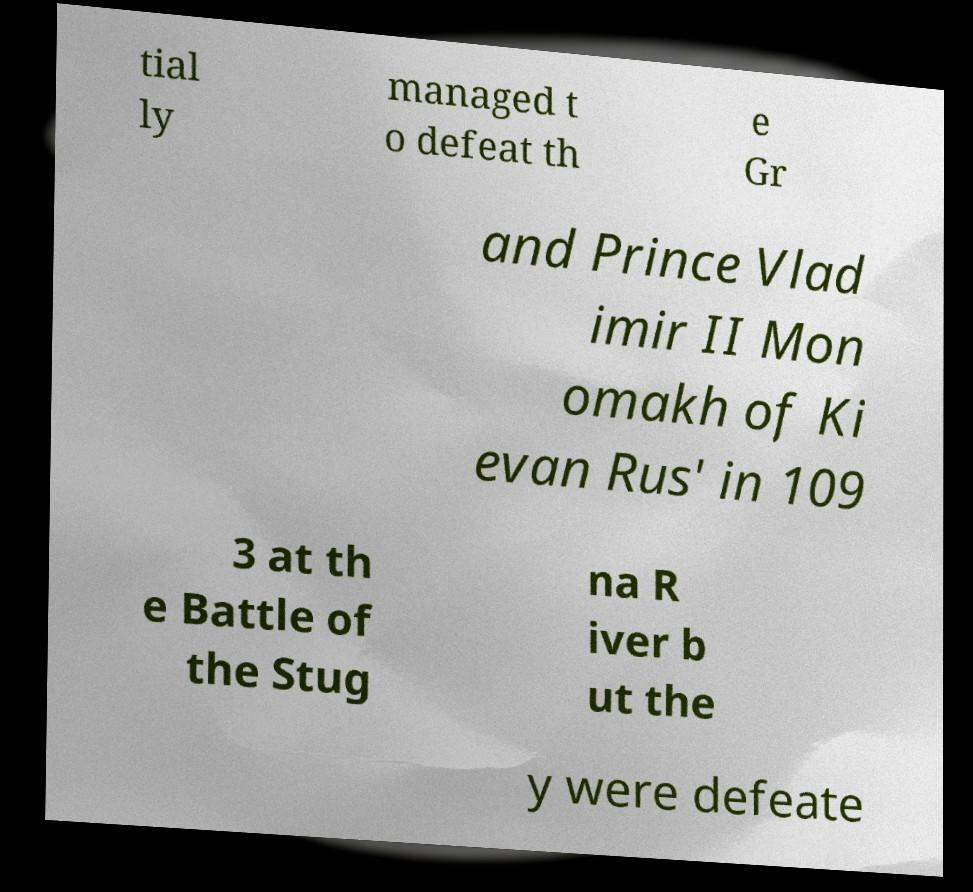For documentation purposes, I need the text within this image transcribed. Could you provide that? tial ly managed t o defeat th e Gr and Prince Vlad imir II Mon omakh of Ki evan Rus' in 109 3 at th e Battle of the Stug na R iver b ut the y were defeate 